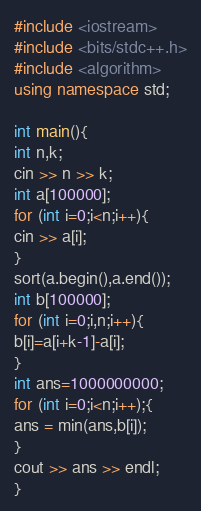<code> <loc_0><loc_0><loc_500><loc_500><_C++_>#include <iostream>
#include <bits/stdc++.h>
#include <algorithm>
using namespace std;

int main(){
int n,k;
cin >> n >> k;
int a[100000];
for (int i=0;i<n;i++){
cin >> a[i];
}
sort(a.begin(),a.end());
int b[100000];
for (int i=0;i,n;i++){
b[i]=a[i+k-1]-a[i];
}
int ans=1000000000;
for (int i=0;i<n;i++);{
ans = min(ans,b[i]);
}
cout >> ans >> endl;
}
</code> 